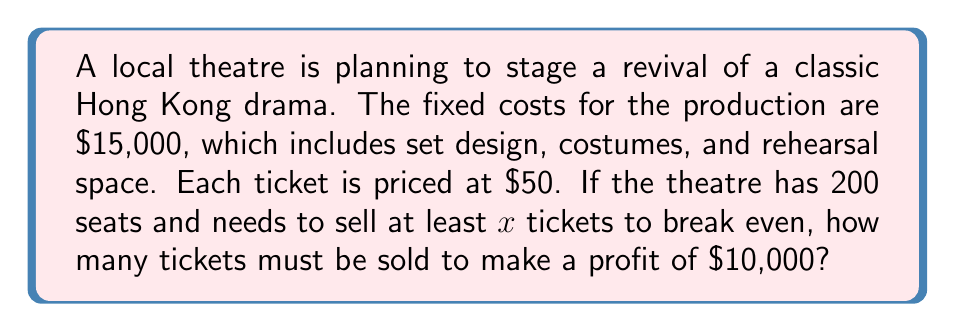Provide a solution to this math problem. Let's approach this step-by-step:

1. First, we need to find the break-even point. At this point, the revenue equals the fixed costs:
   $$ 50x = 15000 $$
   $$ x = 300 $$
   So, 300 tickets need to be sold to break even.

2. Now, to make a profit of $10,000, the revenue needs to exceed the fixed costs by $10,000:
   $$ 50y - 15000 = 10000 $$
   Where $y$ is the number of tickets we need to sell.

3. Solve for $y$:
   $$ 50y = 25000 $$
   $$ y = 500 $$

4. Therefore, 500 tickets need to be sold to make a profit of $10,000.

5. To verify:
   Revenue: $50 \times 500 = $25,000
   Fixed Costs: $15,000
   Profit: $25,000 - $15,000 = $10,000

So, selling 500 tickets will indeed result in a profit of $10,000.
Answer: 500 tickets 